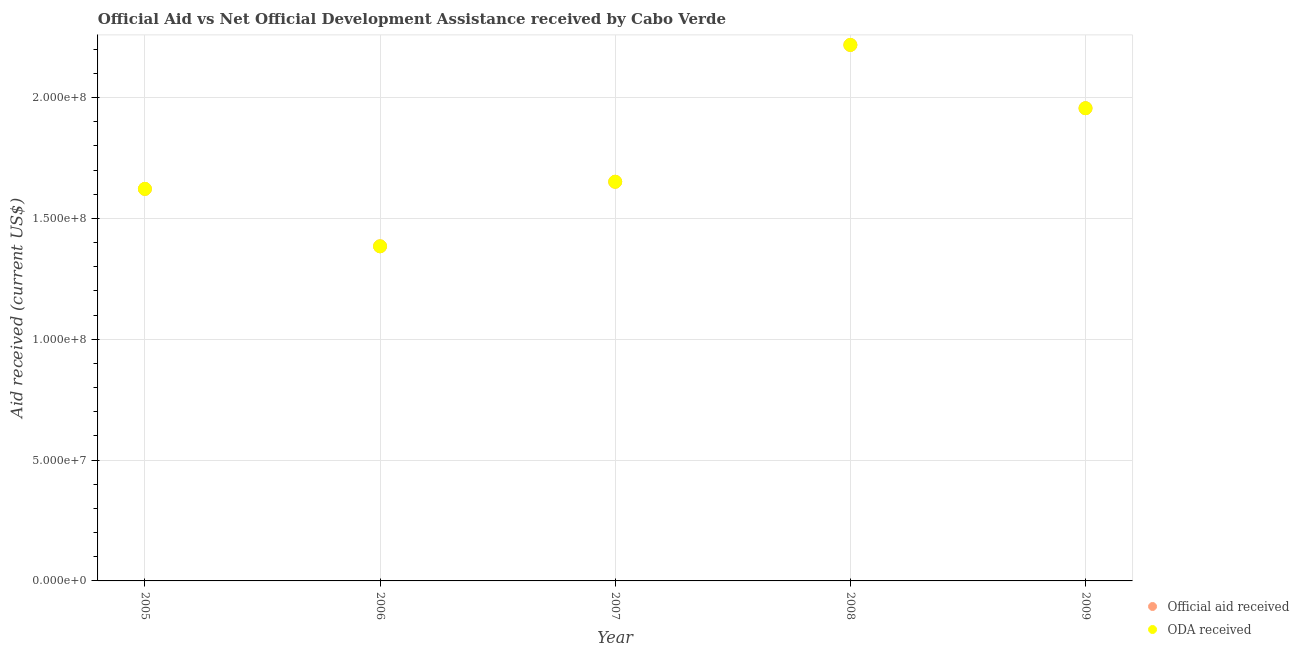What is the official aid received in 2009?
Give a very brief answer. 1.96e+08. Across all years, what is the maximum official aid received?
Your response must be concise. 2.22e+08. Across all years, what is the minimum oda received?
Offer a terse response. 1.38e+08. In which year was the official aid received minimum?
Provide a succinct answer. 2006. What is the total oda received in the graph?
Give a very brief answer. 8.83e+08. What is the difference between the oda received in 2007 and that in 2008?
Make the answer very short. -5.66e+07. What is the difference between the official aid received in 2008 and the oda received in 2009?
Ensure brevity in your answer.  2.62e+07. What is the average official aid received per year?
Provide a short and direct response. 1.77e+08. What is the ratio of the official aid received in 2005 to that in 2006?
Your response must be concise. 1.17. Is the oda received in 2007 less than that in 2009?
Give a very brief answer. Yes. What is the difference between the highest and the second highest oda received?
Provide a short and direct response. 2.62e+07. What is the difference between the highest and the lowest official aid received?
Your answer should be very brief. 8.33e+07. Does the oda received monotonically increase over the years?
Offer a terse response. No. Is the oda received strictly greater than the official aid received over the years?
Provide a succinct answer. No. How many dotlines are there?
Your answer should be compact. 2. What is the difference between two consecutive major ticks on the Y-axis?
Give a very brief answer. 5.00e+07. Does the graph contain grids?
Ensure brevity in your answer.  Yes. How many legend labels are there?
Make the answer very short. 2. What is the title of the graph?
Your response must be concise. Official Aid vs Net Official Development Assistance received by Cabo Verde . Does "Excluding technical cooperation" appear as one of the legend labels in the graph?
Your response must be concise. No. What is the label or title of the Y-axis?
Provide a short and direct response. Aid received (current US$). What is the Aid received (current US$) in Official aid received in 2005?
Your answer should be very brief. 1.62e+08. What is the Aid received (current US$) in ODA received in 2005?
Offer a terse response. 1.62e+08. What is the Aid received (current US$) in Official aid received in 2006?
Your answer should be compact. 1.38e+08. What is the Aid received (current US$) in ODA received in 2006?
Offer a very short reply. 1.38e+08. What is the Aid received (current US$) in Official aid received in 2007?
Give a very brief answer. 1.65e+08. What is the Aid received (current US$) in ODA received in 2007?
Your response must be concise. 1.65e+08. What is the Aid received (current US$) of Official aid received in 2008?
Provide a succinct answer. 2.22e+08. What is the Aid received (current US$) in ODA received in 2008?
Offer a terse response. 2.22e+08. What is the Aid received (current US$) of Official aid received in 2009?
Your response must be concise. 1.96e+08. What is the Aid received (current US$) of ODA received in 2009?
Ensure brevity in your answer.  1.96e+08. Across all years, what is the maximum Aid received (current US$) in Official aid received?
Ensure brevity in your answer.  2.22e+08. Across all years, what is the maximum Aid received (current US$) of ODA received?
Your answer should be compact. 2.22e+08. Across all years, what is the minimum Aid received (current US$) in Official aid received?
Your answer should be very brief. 1.38e+08. Across all years, what is the minimum Aid received (current US$) in ODA received?
Give a very brief answer. 1.38e+08. What is the total Aid received (current US$) in Official aid received in the graph?
Keep it short and to the point. 8.83e+08. What is the total Aid received (current US$) of ODA received in the graph?
Offer a terse response. 8.83e+08. What is the difference between the Aid received (current US$) in Official aid received in 2005 and that in 2006?
Offer a terse response. 2.38e+07. What is the difference between the Aid received (current US$) of ODA received in 2005 and that in 2006?
Ensure brevity in your answer.  2.38e+07. What is the difference between the Aid received (current US$) of Official aid received in 2005 and that in 2007?
Give a very brief answer. -2.95e+06. What is the difference between the Aid received (current US$) of ODA received in 2005 and that in 2007?
Offer a very short reply. -2.95e+06. What is the difference between the Aid received (current US$) in Official aid received in 2005 and that in 2008?
Give a very brief answer. -5.96e+07. What is the difference between the Aid received (current US$) in ODA received in 2005 and that in 2008?
Give a very brief answer. -5.96e+07. What is the difference between the Aid received (current US$) of Official aid received in 2005 and that in 2009?
Make the answer very short. -3.34e+07. What is the difference between the Aid received (current US$) of ODA received in 2005 and that in 2009?
Provide a succinct answer. -3.34e+07. What is the difference between the Aid received (current US$) in Official aid received in 2006 and that in 2007?
Your answer should be very brief. -2.67e+07. What is the difference between the Aid received (current US$) of ODA received in 2006 and that in 2007?
Your answer should be very brief. -2.67e+07. What is the difference between the Aid received (current US$) of Official aid received in 2006 and that in 2008?
Offer a terse response. -8.33e+07. What is the difference between the Aid received (current US$) of ODA received in 2006 and that in 2008?
Your answer should be compact. -8.33e+07. What is the difference between the Aid received (current US$) of Official aid received in 2006 and that in 2009?
Make the answer very short. -5.71e+07. What is the difference between the Aid received (current US$) of ODA received in 2006 and that in 2009?
Provide a succinct answer. -5.71e+07. What is the difference between the Aid received (current US$) in Official aid received in 2007 and that in 2008?
Ensure brevity in your answer.  -5.66e+07. What is the difference between the Aid received (current US$) in ODA received in 2007 and that in 2008?
Your response must be concise. -5.66e+07. What is the difference between the Aid received (current US$) in Official aid received in 2007 and that in 2009?
Provide a succinct answer. -3.04e+07. What is the difference between the Aid received (current US$) in ODA received in 2007 and that in 2009?
Offer a very short reply. -3.04e+07. What is the difference between the Aid received (current US$) in Official aid received in 2008 and that in 2009?
Provide a short and direct response. 2.62e+07. What is the difference between the Aid received (current US$) of ODA received in 2008 and that in 2009?
Your answer should be compact. 2.62e+07. What is the difference between the Aid received (current US$) of Official aid received in 2005 and the Aid received (current US$) of ODA received in 2006?
Make the answer very short. 2.38e+07. What is the difference between the Aid received (current US$) of Official aid received in 2005 and the Aid received (current US$) of ODA received in 2007?
Keep it short and to the point. -2.95e+06. What is the difference between the Aid received (current US$) of Official aid received in 2005 and the Aid received (current US$) of ODA received in 2008?
Your response must be concise. -5.96e+07. What is the difference between the Aid received (current US$) in Official aid received in 2005 and the Aid received (current US$) in ODA received in 2009?
Offer a terse response. -3.34e+07. What is the difference between the Aid received (current US$) of Official aid received in 2006 and the Aid received (current US$) of ODA received in 2007?
Keep it short and to the point. -2.67e+07. What is the difference between the Aid received (current US$) of Official aid received in 2006 and the Aid received (current US$) of ODA received in 2008?
Provide a short and direct response. -8.33e+07. What is the difference between the Aid received (current US$) of Official aid received in 2006 and the Aid received (current US$) of ODA received in 2009?
Offer a terse response. -5.71e+07. What is the difference between the Aid received (current US$) of Official aid received in 2007 and the Aid received (current US$) of ODA received in 2008?
Offer a very short reply. -5.66e+07. What is the difference between the Aid received (current US$) of Official aid received in 2007 and the Aid received (current US$) of ODA received in 2009?
Your response must be concise. -3.04e+07. What is the difference between the Aid received (current US$) in Official aid received in 2008 and the Aid received (current US$) in ODA received in 2009?
Provide a succinct answer. 2.62e+07. What is the average Aid received (current US$) in Official aid received per year?
Your answer should be compact. 1.77e+08. What is the average Aid received (current US$) of ODA received per year?
Make the answer very short. 1.77e+08. In the year 2005, what is the difference between the Aid received (current US$) of Official aid received and Aid received (current US$) of ODA received?
Offer a terse response. 0. In the year 2007, what is the difference between the Aid received (current US$) in Official aid received and Aid received (current US$) in ODA received?
Give a very brief answer. 0. What is the ratio of the Aid received (current US$) in Official aid received in 2005 to that in 2006?
Provide a short and direct response. 1.17. What is the ratio of the Aid received (current US$) in ODA received in 2005 to that in 2006?
Provide a succinct answer. 1.17. What is the ratio of the Aid received (current US$) of Official aid received in 2005 to that in 2007?
Your response must be concise. 0.98. What is the ratio of the Aid received (current US$) in ODA received in 2005 to that in 2007?
Offer a very short reply. 0.98. What is the ratio of the Aid received (current US$) of Official aid received in 2005 to that in 2008?
Offer a terse response. 0.73. What is the ratio of the Aid received (current US$) in ODA received in 2005 to that in 2008?
Provide a short and direct response. 0.73. What is the ratio of the Aid received (current US$) in Official aid received in 2005 to that in 2009?
Make the answer very short. 0.83. What is the ratio of the Aid received (current US$) in ODA received in 2005 to that in 2009?
Give a very brief answer. 0.83. What is the ratio of the Aid received (current US$) of Official aid received in 2006 to that in 2007?
Keep it short and to the point. 0.84. What is the ratio of the Aid received (current US$) in ODA received in 2006 to that in 2007?
Provide a short and direct response. 0.84. What is the ratio of the Aid received (current US$) of Official aid received in 2006 to that in 2008?
Offer a very short reply. 0.62. What is the ratio of the Aid received (current US$) in ODA received in 2006 to that in 2008?
Offer a terse response. 0.62. What is the ratio of the Aid received (current US$) in Official aid received in 2006 to that in 2009?
Give a very brief answer. 0.71. What is the ratio of the Aid received (current US$) of ODA received in 2006 to that in 2009?
Your response must be concise. 0.71. What is the ratio of the Aid received (current US$) of Official aid received in 2007 to that in 2008?
Your answer should be compact. 0.74. What is the ratio of the Aid received (current US$) in ODA received in 2007 to that in 2008?
Provide a short and direct response. 0.74. What is the ratio of the Aid received (current US$) of Official aid received in 2007 to that in 2009?
Offer a very short reply. 0.84. What is the ratio of the Aid received (current US$) in ODA received in 2007 to that in 2009?
Offer a terse response. 0.84. What is the ratio of the Aid received (current US$) of Official aid received in 2008 to that in 2009?
Offer a terse response. 1.13. What is the ratio of the Aid received (current US$) in ODA received in 2008 to that in 2009?
Give a very brief answer. 1.13. What is the difference between the highest and the second highest Aid received (current US$) in Official aid received?
Keep it short and to the point. 2.62e+07. What is the difference between the highest and the second highest Aid received (current US$) of ODA received?
Keep it short and to the point. 2.62e+07. What is the difference between the highest and the lowest Aid received (current US$) of Official aid received?
Make the answer very short. 8.33e+07. What is the difference between the highest and the lowest Aid received (current US$) in ODA received?
Offer a very short reply. 8.33e+07. 